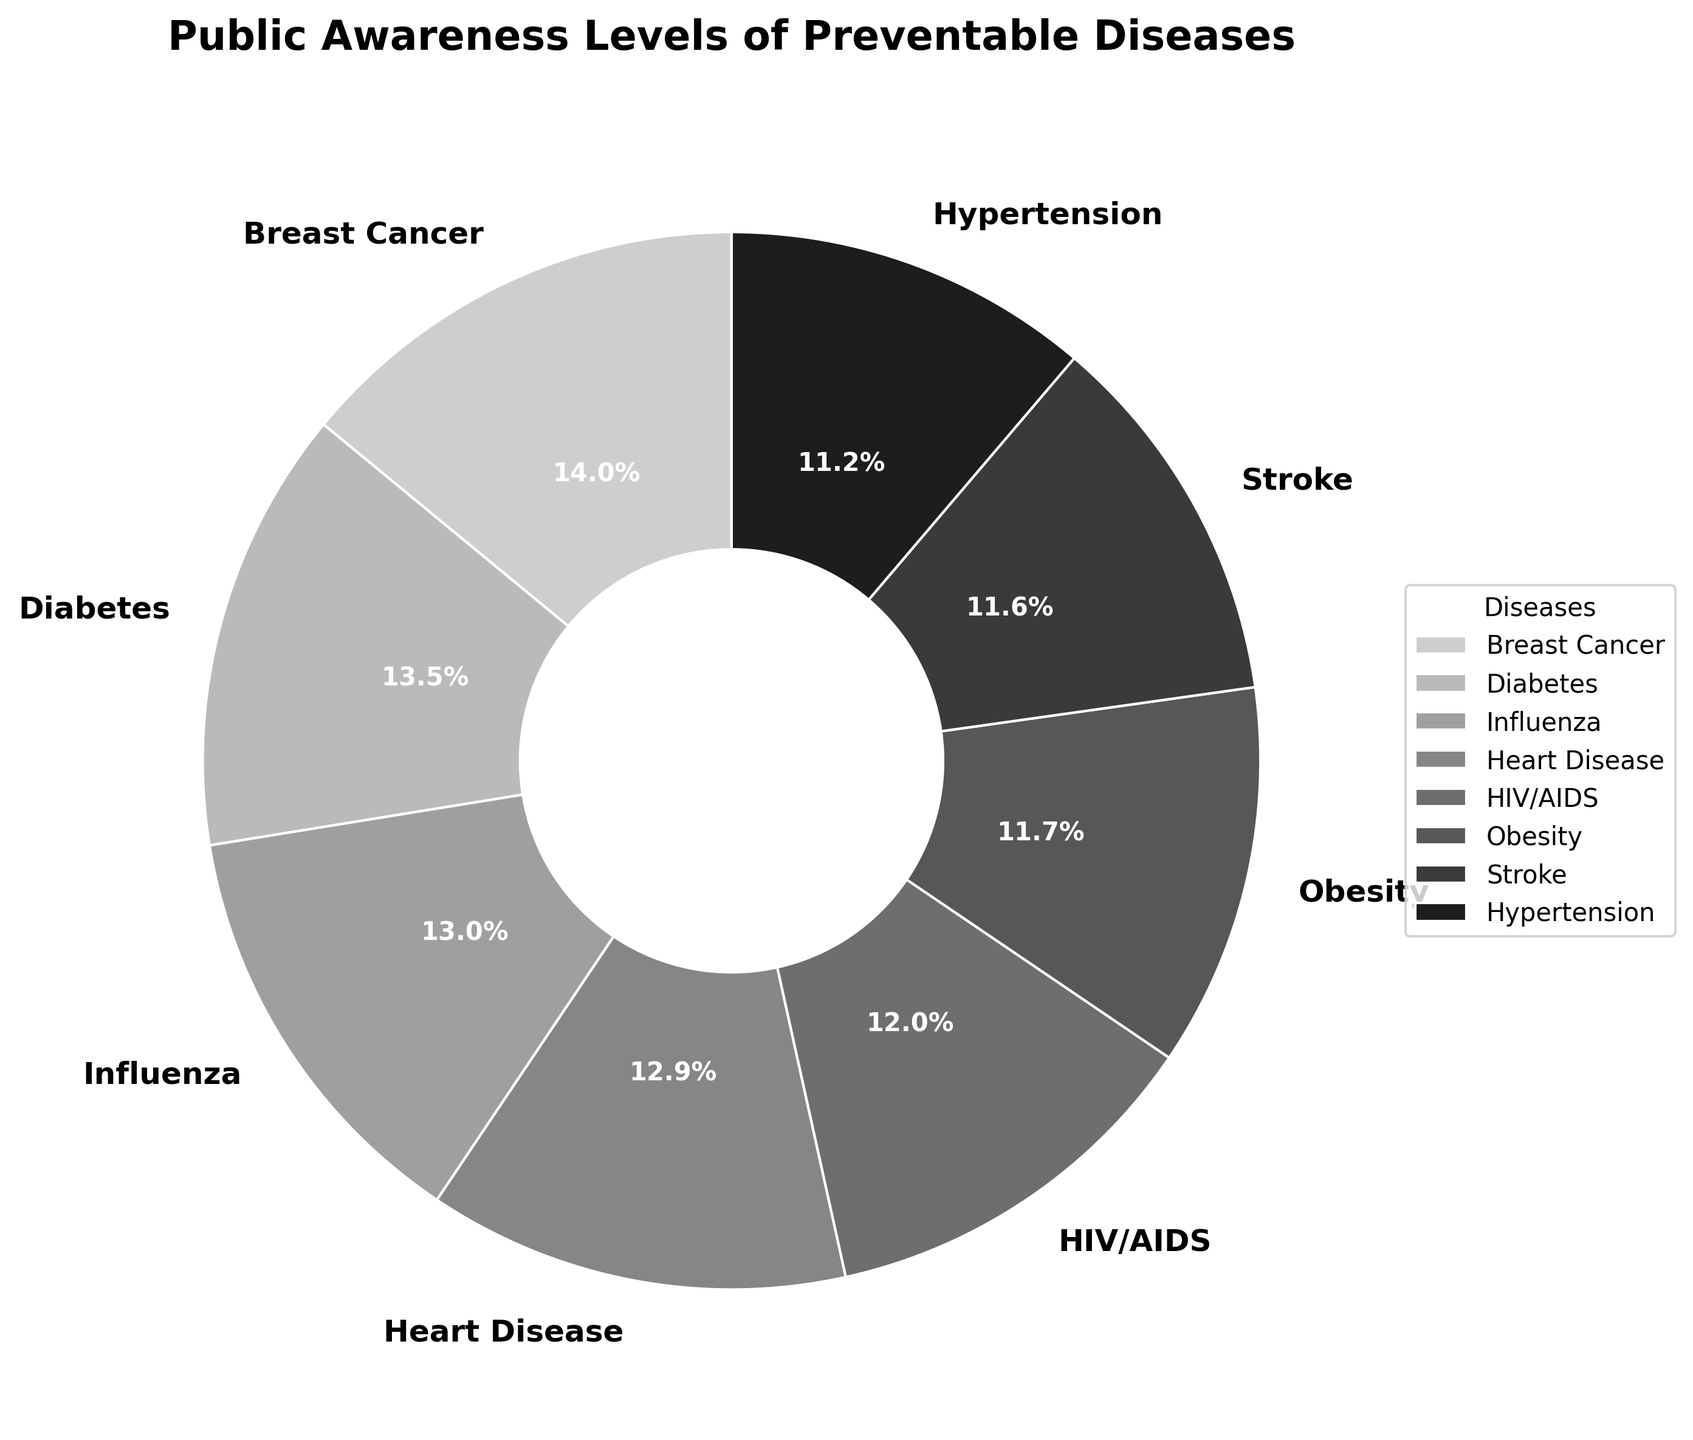Which disease has the highest public awareness level? The figure shows a pie chart with different segments representing public awareness percentages of various diseases. The segment with the largest percentage is Breast Cancer at 85%.
Answer: Breast Cancer Which disease has the lowest public awareness level in the top 8 diseases shown? The pie chart displays the top 8 diseases by public awareness levels, sorted in descending order. The smallest segment among the top 8 is Skin Cancer at 59%.
Answer: Skin Cancer How does the awareness level of Obesity compare to that of HIV/AIDS? By looking at the sizes of the pie chart segments, we find that Obesity's public awareness level is 71%, whereas HIV/AIDS's awareness level is 73%. Since 73% is greater than 71%, HIV/AIDS has a higher awareness level than Obesity.
Answer: HIV/AIDS is higher What is the combined awareness percentage for the top 3 diseases? The top 3 diseases from the pie chart are Breast Cancer (85%), Diabetes (82%), and Influenza (79%). Adding these percentages together: 85 + 82 + 79 = 246%.
Answer: 246% What visual characteristic helps to distinguish different segments in the pie chart? The pie chart uses different shades of grey to differentiate the segments. Each disease has a unique grey shade, making the segments visually distinct.
Answer: Different shades of grey Calculate the average public awareness level of the top 4 preventable diseases. The top 4 diseases are Breast Cancer (85%), Diabetes (82%), Influenza (79%), and Heart Disease (78%). Sum these percentages and divide by 4: (85 + 82 + 79 + 78) / 4 = 324 / 4 = 81%.
Answer: 81% Between Heart Disease and Stroke, which has a higher awareness level and by how much? Heart Disease has an awareness level of 78%, and Stroke has an awareness level of 70%. The difference is 78% - 70% = 8%.
Answer: Heart Disease by 8% How does the awareness level of Colorectal Cancer compare to the lowest awareness level in the top 8 diseases? Colorectal Cancer has an awareness level of 51%, and the lowest awareness level among the top 8 is Skin Cancer at 59%. 51% is less than 59%, so Colorectal Cancer has a lower awareness level.
Answer: Colorectal Cancer is lower What is the range of awareness percentages among the top 8 preventable diseases? The highest awareness level in the top 8 is Breast Cancer at 85% and the lowest is Skin Cancer at 59%. The range is 85% - 59% = 26%.
Answer: 26% 